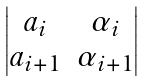Convert formula to latex. <formula><loc_0><loc_0><loc_500><loc_500>\begin{vmatrix} a _ { i } & \alpha _ { i } \\ a _ { i + 1 } & \alpha _ { i + 1 } \end{vmatrix}</formula> 